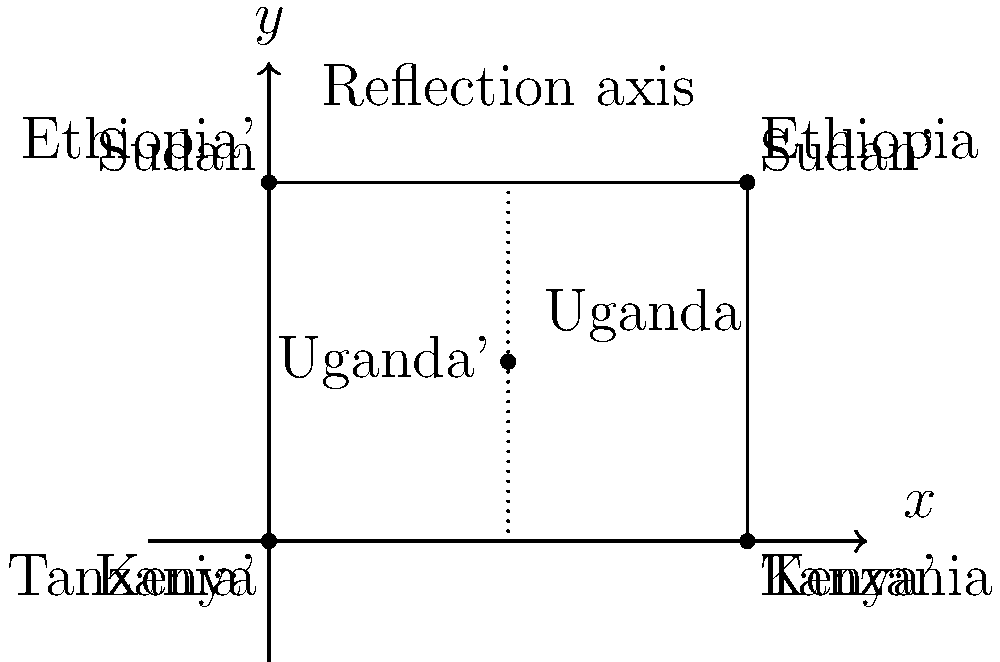In a collaborative project between Indian and Chinese philanthropists, the map shows the locations of joint initiatives in five African countries. The original map is transformed through a series of geometric operations. If the first transformation is a reflection across the line $x=2$, what would be the coordinates of Uganda's new position (Uganda') after this reflection? To solve this problem, we need to follow these steps:

1. Identify the original coordinates of Uganda:
   Uganda is located at point E with coordinates (2, 1.5)

2. Understand the reflection:
   The reflection is across the line x = 2

3. Apply the reflection:
   For a reflection across a vertical line x = a, the transformation is:
   $(x, y) \rightarrow (2a - x, y)$

   In this case, a = 2, so the transformation is:
   $(x, y) \rightarrow (4 - x, y)$

4. Calculate the new coordinates:
   For Uganda (2, 1.5):
   $x' = 4 - 2 = 2$
   $y' = 1.5$ (y-coordinate remains unchanged in a vertical reflection)

Therefore, the new coordinates of Uganda' after the reflection are (2, 1.5).
Answer: (2, 1.5) 